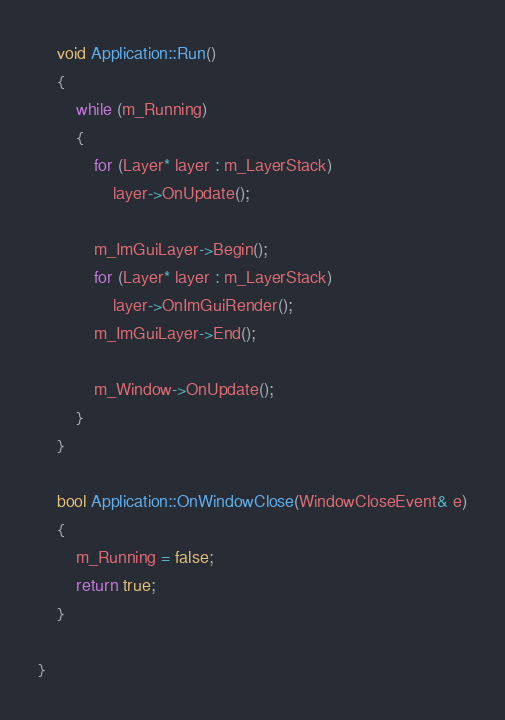Convert code to text. <code><loc_0><loc_0><loc_500><loc_500><_C++_>	void Application::Run()
	{
		while (m_Running)
		{
			for (Layer* layer : m_LayerStack)
				layer->OnUpdate();

			m_ImGuiLayer->Begin();
			for (Layer* layer : m_LayerStack)
				layer->OnImGuiRender();
			m_ImGuiLayer->End();

			m_Window->OnUpdate();
		}
	}

	bool Application::OnWindowClose(WindowCloseEvent& e)
	{
		m_Running = false;
		return true;
	}

}</code> 